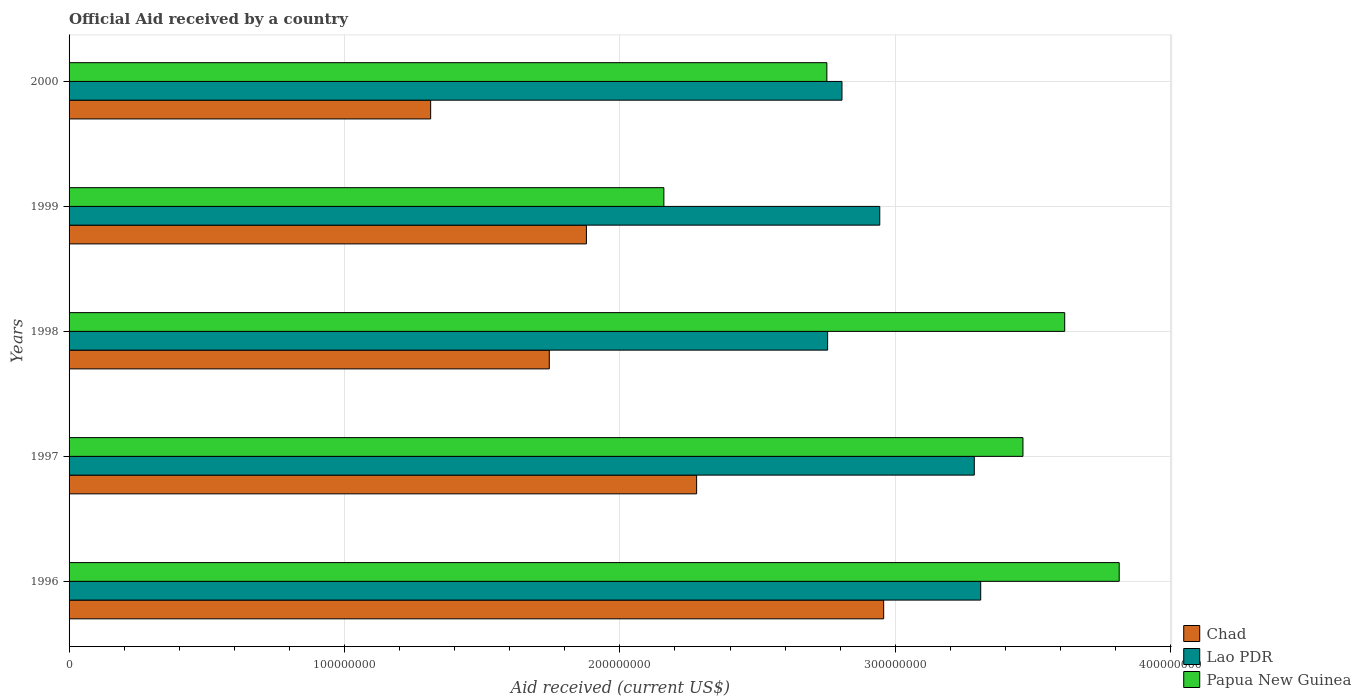How many groups of bars are there?
Offer a terse response. 5. Are the number of bars per tick equal to the number of legend labels?
Provide a short and direct response. Yes. How many bars are there on the 4th tick from the top?
Make the answer very short. 3. What is the label of the 4th group of bars from the top?
Offer a terse response. 1997. In how many cases, is the number of bars for a given year not equal to the number of legend labels?
Give a very brief answer. 0. What is the net official aid received in Chad in 2000?
Ensure brevity in your answer.  1.31e+08. Across all years, what is the maximum net official aid received in Chad?
Give a very brief answer. 2.96e+08. Across all years, what is the minimum net official aid received in Chad?
Provide a short and direct response. 1.31e+08. In which year was the net official aid received in Lao PDR maximum?
Your response must be concise. 1996. What is the total net official aid received in Lao PDR in the graph?
Provide a short and direct response. 1.51e+09. What is the difference between the net official aid received in Papua New Guinea in 1996 and that in 1998?
Ensure brevity in your answer.  1.98e+07. What is the difference between the net official aid received in Papua New Guinea in 2000 and the net official aid received in Lao PDR in 1998?
Your answer should be very brief. -2.80e+05. What is the average net official aid received in Papua New Guinea per year?
Offer a terse response. 3.16e+08. In the year 1996, what is the difference between the net official aid received in Papua New Guinea and net official aid received in Chad?
Your answer should be very brief. 8.55e+07. In how many years, is the net official aid received in Papua New Guinea greater than 300000000 US$?
Offer a terse response. 3. What is the ratio of the net official aid received in Lao PDR in 1997 to that in 1999?
Your answer should be compact. 1.12. Is the net official aid received in Lao PDR in 1996 less than that in 1998?
Give a very brief answer. No. Is the difference between the net official aid received in Papua New Guinea in 1998 and 2000 greater than the difference between the net official aid received in Chad in 1998 and 2000?
Make the answer very short. Yes. What is the difference between the highest and the second highest net official aid received in Papua New Guinea?
Your response must be concise. 1.98e+07. What is the difference between the highest and the lowest net official aid received in Lao PDR?
Make the answer very short. 5.56e+07. In how many years, is the net official aid received in Papua New Guinea greater than the average net official aid received in Papua New Guinea taken over all years?
Provide a short and direct response. 3. What does the 2nd bar from the top in 1997 represents?
Offer a very short reply. Lao PDR. What does the 2nd bar from the bottom in 2000 represents?
Provide a short and direct response. Lao PDR. Are all the bars in the graph horizontal?
Provide a short and direct response. Yes. How many years are there in the graph?
Keep it short and to the point. 5. What is the difference between two consecutive major ticks on the X-axis?
Keep it short and to the point. 1.00e+08. Does the graph contain grids?
Your answer should be compact. Yes. Where does the legend appear in the graph?
Ensure brevity in your answer.  Bottom right. How many legend labels are there?
Provide a succinct answer. 3. How are the legend labels stacked?
Give a very brief answer. Vertical. What is the title of the graph?
Provide a short and direct response. Official Aid received by a country. Does "Antigua and Barbuda" appear as one of the legend labels in the graph?
Your response must be concise. No. What is the label or title of the X-axis?
Give a very brief answer. Aid received (current US$). What is the label or title of the Y-axis?
Keep it short and to the point. Years. What is the Aid received (current US$) in Chad in 1996?
Provide a short and direct response. 2.96e+08. What is the Aid received (current US$) of Lao PDR in 1996?
Provide a succinct answer. 3.31e+08. What is the Aid received (current US$) of Papua New Guinea in 1996?
Provide a short and direct response. 3.81e+08. What is the Aid received (current US$) in Chad in 1997?
Give a very brief answer. 2.28e+08. What is the Aid received (current US$) of Lao PDR in 1997?
Provide a succinct answer. 3.29e+08. What is the Aid received (current US$) of Papua New Guinea in 1997?
Keep it short and to the point. 3.46e+08. What is the Aid received (current US$) in Chad in 1998?
Your response must be concise. 1.74e+08. What is the Aid received (current US$) in Lao PDR in 1998?
Provide a succinct answer. 2.75e+08. What is the Aid received (current US$) of Papua New Guinea in 1998?
Your answer should be very brief. 3.62e+08. What is the Aid received (current US$) in Chad in 1999?
Ensure brevity in your answer.  1.88e+08. What is the Aid received (current US$) in Lao PDR in 1999?
Offer a terse response. 2.94e+08. What is the Aid received (current US$) of Papua New Guinea in 1999?
Provide a short and direct response. 2.16e+08. What is the Aid received (current US$) in Chad in 2000?
Your answer should be very brief. 1.31e+08. What is the Aid received (current US$) in Lao PDR in 2000?
Ensure brevity in your answer.  2.81e+08. What is the Aid received (current US$) in Papua New Guinea in 2000?
Your answer should be very brief. 2.75e+08. Across all years, what is the maximum Aid received (current US$) in Chad?
Keep it short and to the point. 2.96e+08. Across all years, what is the maximum Aid received (current US$) of Lao PDR?
Ensure brevity in your answer.  3.31e+08. Across all years, what is the maximum Aid received (current US$) of Papua New Guinea?
Provide a succinct answer. 3.81e+08. Across all years, what is the minimum Aid received (current US$) in Chad?
Offer a very short reply. 1.31e+08. Across all years, what is the minimum Aid received (current US$) of Lao PDR?
Your response must be concise. 2.75e+08. Across all years, what is the minimum Aid received (current US$) in Papua New Guinea?
Offer a very short reply. 2.16e+08. What is the total Aid received (current US$) in Chad in the graph?
Provide a succinct answer. 1.02e+09. What is the total Aid received (current US$) of Lao PDR in the graph?
Your answer should be very brief. 1.51e+09. What is the total Aid received (current US$) in Papua New Guinea in the graph?
Give a very brief answer. 1.58e+09. What is the difference between the Aid received (current US$) of Chad in 1996 and that in 1997?
Keep it short and to the point. 6.79e+07. What is the difference between the Aid received (current US$) of Lao PDR in 1996 and that in 1997?
Provide a succinct answer. 2.33e+06. What is the difference between the Aid received (current US$) in Papua New Guinea in 1996 and that in 1997?
Offer a very short reply. 3.50e+07. What is the difference between the Aid received (current US$) in Chad in 1996 and that in 1998?
Ensure brevity in your answer.  1.21e+08. What is the difference between the Aid received (current US$) in Lao PDR in 1996 and that in 1998?
Your answer should be compact. 5.56e+07. What is the difference between the Aid received (current US$) of Papua New Guinea in 1996 and that in 1998?
Make the answer very short. 1.98e+07. What is the difference between the Aid received (current US$) of Chad in 1996 and that in 1999?
Provide a succinct answer. 1.08e+08. What is the difference between the Aid received (current US$) of Lao PDR in 1996 and that in 1999?
Offer a terse response. 3.66e+07. What is the difference between the Aid received (current US$) of Papua New Guinea in 1996 and that in 1999?
Keep it short and to the point. 1.65e+08. What is the difference between the Aid received (current US$) of Chad in 1996 and that in 2000?
Offer a very short reply. 1.64e+08. What is the difference between the Aid received (current US$) in Lao PDR in 1996 and that in 2000?
Offer a terse response. 5.04e+07. What is the difference between the Aid received (current US$) of Papua New Guinea in 1996 and that in 2000?
Offer a terse response. 1.06e+08. What is the difference between the Aid received (current US$) of Chad in 1997 and that in 1998?
Your response must be concise. 5.35e+07. What is the difference between the Aid received (current US$) of Lao PDR in 1997 and that in 1998?
Offer a very short reply. 5.32e+07. What is the difference between the Aid received (current US$) in Papua New Guinea in 1997 and that in 1998?
Keep it short and to the point. -1.52e+07. What is the difference between the Aid received (current US$) in Chad in 1997 and that in 1999?
Offer a terse response. 4.00e+07. What is the difference between the Aid received (current US$) in Lao PDR in 1997 and that in 1999?
Make the answer very short. 3.43e+07. What is the difference between the Aid received (current US$) of Papua New Guinea in 1997 and that in 1999?
Offer a very short reply. 1.30e+08. What is the difference between the Aid received (current US$) in Chad in 1997 and that in 2000?
Make the answer very short. 9.66e+07. What is the difference between the Aid received (current US$) in Lao PDR in 1997 and that in 2000?
Your answer should be compact. 4.80e+07. What is the difference between the Aid received (current US$) of Papua New Guinea in 1997 and that in 2000?
Offer a terse response. 7.12e+07. What is the difference between the Aid received (current US$) of Chad in 1998 and that in 1999?
Your response must be concise. -1.35e+07. What is the difference between the Aid received (current US$) in Lao PDR in 1998 and that in 1999?
Give a very brief answer. -1.89e+07. What is the difference between the Aid received (current US$) in Papua New Guinea in 1998 and that in 1999?
Keep it short and to the point. 1.46e+08. What is the difference between the Aid received (current US$) of Chad in 1998 and that in 2000?
Provide a short and direct response. 4.31e+07. What is the difference between the Aid received (current US$) in Lao PDR in 1998 and that in 2000?
Your response must be concise. -5.21e+06. What is the difference between the Aid received (current US$) in Papua New Guinea in 1998 and that in 2000?
Offer a very short reply. 8.64e+07. What is the difference between the Aid received (current US$) in Chad in 1999 and that in 2000?
Make the answer very short. 5.66e+07. What is the difference between the Aid received (current US$) in Lao PDR in 1999 and that in 2000?
Make the answer very short. 1.37e+07. What is the difference between the Aid received (current US$) in Papua New Guinea in 1999 and that in 2000?
Ensure brevity in your answer.  -5.92e+07. What is the difference between the Aid received (current US$) of Chad in 1996 and the Aid received (current US$) of Lao PDR in 1997?
Ensure brevity in your answer.  -3.29e+07. What is the difference between the Aid received (current US$) of Chad in 1996 and the Aid received (current US$) of Papua New Guinea in 1997?
Make the answer very short. -5.06e+07. What is the difference between the Aid received (current US$) in Lao PDR in 1996 and the Aid received (current US$) in Papua New Guinea in 1997?
Your answer should be very brief. -1.53e+07. What is the difference between the Aid received (current US$) in Chad in 1996 and the Aid received (current US$) in Lao PDR in 1998?
Your answer should be compact. 2.04e+07. What is the difference between the Aid received (current US$) of Chad in 1996 and the Aid received (current US$) of Papua New Guinea in 1998?
Give a very brief answer. -6.57e+07. What is the difference between the Aid received (current US$) of Lao PDR in 1996 and the Aid received (current US$) of Papua New Guinea in 1998?
Your response must be concise. -3.05e+07. What is the difference between the Aid received (current US$) of Chad in 1996 and the Aid received (current US$) of Lao PDR in 1999?
Offer a very short reply. 1.42e+06. What is the difference between the Aid received (current US$) of Chad in 1996 and the Aid received (current US$) of Papua New Guinea in 1999?
Your response must be concise. 7.98e+07. What is the difference between the Aid received (current US$) of Lao PDR in 1996 and the Aid received (current US$) of Papua New Guinea in 1999?
Make the answer very short. 1.15e+08. What is the difference between the Aid received (current US$) in Chad in 1996 and the Aid received (current US$) in Lao PDR in 2000?
Give a very brief answer. 1.51e+07. What is the difference between the Aid received (current US$) in Chad in 1996 and the Aid received (current US$) in Papua New Guinea in 2000?
Provide a succinct answer. 2.06e+07. What is the difference between the Aid received (current US$) of Lao PDR in 1996 and the Aid received (current US$) of Papua New Guinea in 2000?
Provide a short and direct response. 5.59e+07. What is the difference between the Aid received (current US$) of Chad in 1997 and the Aid received (current US$) of Lao PDR in 1998?
Make the answer very short. -4.76e+07. What is the difference between the Aid received (current US$) of Chad in 1997 and the Aid received (current US$) of Papua New Guinea in 1998?
Provide a short and direct response. -1.34e+08. What is the difference between the Aid received (current US$) of Lao PDR in 1997 and the Aid received (current US$) of Papua New Guinea in 1998?
Give a very brief answer. -3.28e+07. What is the difference between the Aid received (current US$) of Chad in 1997 and the Aid received (current US$) of Lao PDR in 1999?
Keep it short and to the point. -6.65e+07. What is the difference between the Aid received (current US$) in Chad in 1997 and the Aid received (current US$) in Papua New Guinea in 1999?
Your response must be concise. 1.19e+07. What is the difference between the Aid received (current US$) in Lao PDR in 1997 and the Aid received (current US$) in Papua New Guinea in 1999?
Provide a short and direct response. 1.13e+08. What is the difference between the Aid received (current US$) in Chad in 1997 and the Aid received (current US$) in Lao PDR in 2000?
Offer a very short reply. -5.28e+07. What is the difference between the Aid received (current US$) of Chad in 1997 and the Aid received (current US$) of Papua New Guinea in 2000?
Offer a terse response. -4.73e+07. What is the difference between the Aid received (current US$) in Lao PDR in 1997 and the Aid received (current US$) in Papua New Guinea in 2000?
Give a very brief answer. 5.35e+07. What is the difference between the Aid received (current US$) in Chad in 1998 and the Aid received (current US$) in Lao PDR in 1999?
Your response must be concise. -1.20e+08. What is the difference between the Aid received (current US$) in Chad in 1998 and the Aid received (current US$) in Papua New Guinea in 1999?
Make the answer very short. -4.16e+07. What is the difference between the Aid received (current US$) of Lao PDR in 1998 and the Aid received (current US$) of Papua New Guinea in 1999?
Provide a succinct answer. 5.95e+07. What is the difference between the Aid received (current US$) of Chad in 1998 and the Aid received (current US$) of Lao PDR in 2000?
Offer a terse response. -1.06e+08. What is the difference between the Aid received (current US$) in Chad in 1998 and the Aid received (current US$) in Papua New Guinea in 2000?
Your response must be concise. -1.01e+08. What is the difference between the Aid received (current US$) of Chad in 1999 and the Aid received (current US$) of Lao PDR in 2000?
Provide a succinct answer. -9.28e+07. What is the difference between the Aid received (current US$) of Chad in 1999 and the Aid received (current US$) of Papua New Guinea in 2000?
Your answer should be compact. -8.73e+07. What is the difference between the Aid received (current US$) in Lao PDR in 1999 and the Aid received (current US$) in Papua New Guinea in 2000?
Make the answer very short. 1.92e+07. What is the average Aid received (current US$) of Chad per year?
Keep it short and to the point. 2.03e+08. What is the average Aid received (current US$) of Lao PDR per year?
Your response must be concise. 3.02e+08. What is the average Aid received (current US$) of Papua New Guinea per year?
Make the answer very short. 3.16e+08. In the year 1996, what is the difference between the Aid received (current US$) of Chad and Aid received (current US$) of Lao PDR?
Ensure brevity in your answer.  -3.52e+07. In the year 1996, what is the difference between the Aid received (current US$) in Chad and Aid received (current US$) in Papua New Guinea?
Provide a succinct answer. -8.55e+07. In the year 1996, what is the difference between the Aid received (current US$) in Lao PDR and Aid received (current US$) in Papua New Guinea?
Give a very brief answer. -5.03e+07. In the year 1997, what is the difference between the Aid received (current US$) in Chad and Aid received (current US$) in Lao PDR?
Keep it short and to the point. -1.01e+08. In the year 1997, what is the difference between the Aid received (current US$) in Chad and Aid received (current US$) in Papua New Guinea?
Your answer should be compact. -1.18e+08. In the year 1997, what is the difference between the Aid received (current US$) in Lao PDR and Aid received (current US$) in Papua New Guinea?
Ensure brevity in your answer.  -1.77e+07. In the year 1998, what is the difference between the Aid received (current US$) of Chad and Aid received (current US$) of Lao PDR?
Make the answer very short. -1.01e+08. In the year 1998, what is the difference between the Aid received (current US$) in Chad and Aid received (current US$) in Papua New Guinea?
Provide a short and direct response. -1.87e+08. In the year 1998, what is the difference between the Aid received (current US$) in Lao PDR and Aid received (current US$) in Papua New Guinea?
Make the answer very short. -8.61e+07. In the year 1999, what is the difference between the Aid received (current US$) in Chad and Aid received (current US$) in Lao PDR?
Offer a terse response. -1.07e+08. In the year 1999, what is the difference between the Aid received (current US$) in Chad and Aid received (current US$) in Papua New Guinea?
Provide a short and direct response. -2.81e+07. In the year 1999, what is the difference between the Aid received (current US$) of Lao PDR and Aid received (current US$) of Papua New Guinea?
Give a very brief answer. 7.84e+07. In the year 2000, what is the difference between the Aid received (current US$) in Chad and Aid received (current US$) in Lao PDR?
Provide a succinct answer. -1.49e+08. In the year 2000, what is the difference between the Aid received (current US$) in Chad and Aid received (current US$) in Papua New Guinea?
Provide a succinct answer. -1.44e+08. In the year 2000, what is the difference between the Aid received (current US$) in Lao PDR and Aid received (current US$) in Papua New Guinea?
Provide a short and direct response. 5.49e+06. What is the ratio of the Aid received (current US$) in Chad in 1996 to that in 1997?
Provide a succinct answer. 1.3. What is the ratio of the Aid received (current US$) of Lao PDR in 1996 to that in 1997?
Your response must be concise. 1.01. What is the ratio of the Aid received (current US$) in Papua New Guinea in 1996 to that in 1997?
Provide a short and direct response. 1.1. What is the ratio of the Aid received (current US$) of Chad in 1996 to that in 1998?
Keep it short and to the point. 1.7. What is the ratio of the Aid received (current US$) in Lao PDR in 1996 to that in 1998?
Your answer should be very brief. 1.2. What is the ratio of the Aid received (current US$) of Papua New Guinea in 1996 to that in 1998?
Offer a very short reply. 1.05. What is the ratio of the Aid received (current US$) of Chad in 1996 to that in 1999?
Keep it short and to the point. 1.57. What is the ratio of the Aid received (current US$) of Lao PDR in 1996 to that in 1999?
Offer a very short reply. 1.12. What is the ratio of the Aid received (current US$) in Papua New Guinea in 1996 to that in 1999?
Provide a succinct answer. 1.77. What is the ratio of the Aid received (current US$) in Chad in 1996 to that in 2000?
Offer a terse response. 2.25. What is the ratio of the Aid received (current US$) in Lao PDR in 1996 to that in 2000?
Provide a succinct answer. 1.18. What is the ratio of the Aid received (current US$) in Papua New Guinea in 1996 to that in 2000?
Ensure brevity in your answer.  1.39. What is the ratio of the Aid received (current US$) of Chad in 1997 to that in 1998?
Provide a short and direct response. 1.31. What is the ratio of the Aid received (current US$) in Lao PDR in 1997 to that in 1998?
Your answer should be compact. 1.19. What is the ratio of the Aid received (current US$) of Papua New Guinea in 1997 to that in 1998?
Keep it short and to the point. 0.96. What is the ratio of the Aid received (current US$) of Chad in 1997 to that in 1999?
Provide a short and direct response. 1.21. What is the ratio of the Aid received (current US$) in Lao PDR in 1997 to that in 1999?
Keep it short and to the point. 1.12. What is the ratio of the Aid received (current US$) in Papua New Guinea in 1997 to that in 1999?
Give a very brief answer. 1.6. What is the ratio of the Aid received (current US$) in Chad in 1997 to that in 2000?
Offer a terse response. 1.74. What is the ratio of the Aid received (current US$) in Lao PDR in 1997 to that in 2000?
Your response must be concise. 1.17. What is the ratio of the Aid received (current US$) in Papua New Guinea in 1997 to that in 2000?
Your answer should be compact. 1.26. What is the ratio of the Aid received (current US$) in Chad in 1998 to that in 1999?
Ensure brevity in your answer.  0.93. What is the ratio of the Aid received (current US$) in Lao PDR in 1998 to that in 1999?
Ensure brevity in your answer.  0.94. What is the ratio of the Aid received (current US$) of Papua New Guinea in 1998 to that in 1999?
Your answer should be compact. 1.67. What is the ratio of the Aid received (current US$) of Chad in 1998 to that in 2000?
Your answer should be compact. 1.33. What is the ratio of the Aid received (current US$) of Lao PDR in 1998 to that in 2000?
Make the answer very short. 0.98. What is the ratio of the Aid received (current US$) in Papua New Guinea in 1998 to that in 2000?
Make the answer very short. 1.31. What is the ratio of the Aid received (current US$) in Chad in 1999 to that in 2000?
Your response must be concise. 1.43. What is the ratio of the Aid received (current US$) of Lao PDR in 1999 to that in 2000?
Keep it short and to the point. 1.05. What is the ratio of the Aid received (current US$) in Papua New Guinea in 1999 to that in 2000?
Ensure brevity in your answer.  0.78. What is the difference between the highest and the second highest Aid received (current US$) in Chad?
Your answer should be very brief. 6.79e+07. What is the difference between the highest and the second highest Aid received (current US$) in Lao PDR?
Provide a short and direct response. 2.33e+06. What is the difference between the highest and the second highest Aid received (current US$) of Papua New Guinea?
Your answer should be very brief. 1.98e+07. What is the difference between the highest and the lowest Aid received (current US$) of Chad?
Your answer should be compact. 1.64e+08. What is the difference between the highest and the lowest Aid received (current US$) in Lao PDR?
Make the answer very short. 5.56e+07. What is the difference between the highest and the lowest Aid received (current US$) in Papua New Guinea?
Offer a terse response. 1.65e+08. 